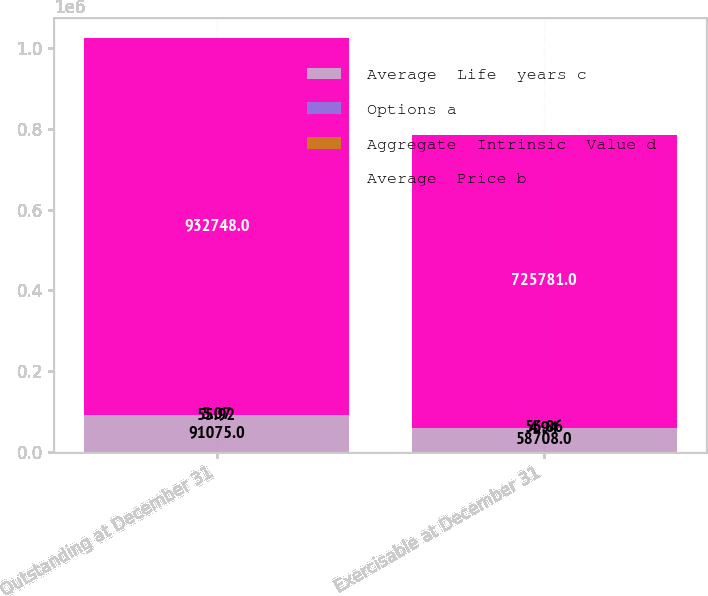<chart> <loc_0><loc_0><loc_500><loc_500><stacked_bar_chart><ecel><fcel>Outstanding at December 31<fcel>Exercisable at December 31<nl><fcel>Average  Life  years c<fcel>91075<fcel>58708<nl><fcel>Options a<fcel>55.92<fcel>53.86<nl><fcel>Aggregate  Intrinsic  Value d<fcel>5.07<fcel>4.94<nl><fcel>Average  Price b<fcel>932748<fcel>725781<nl></chart> 